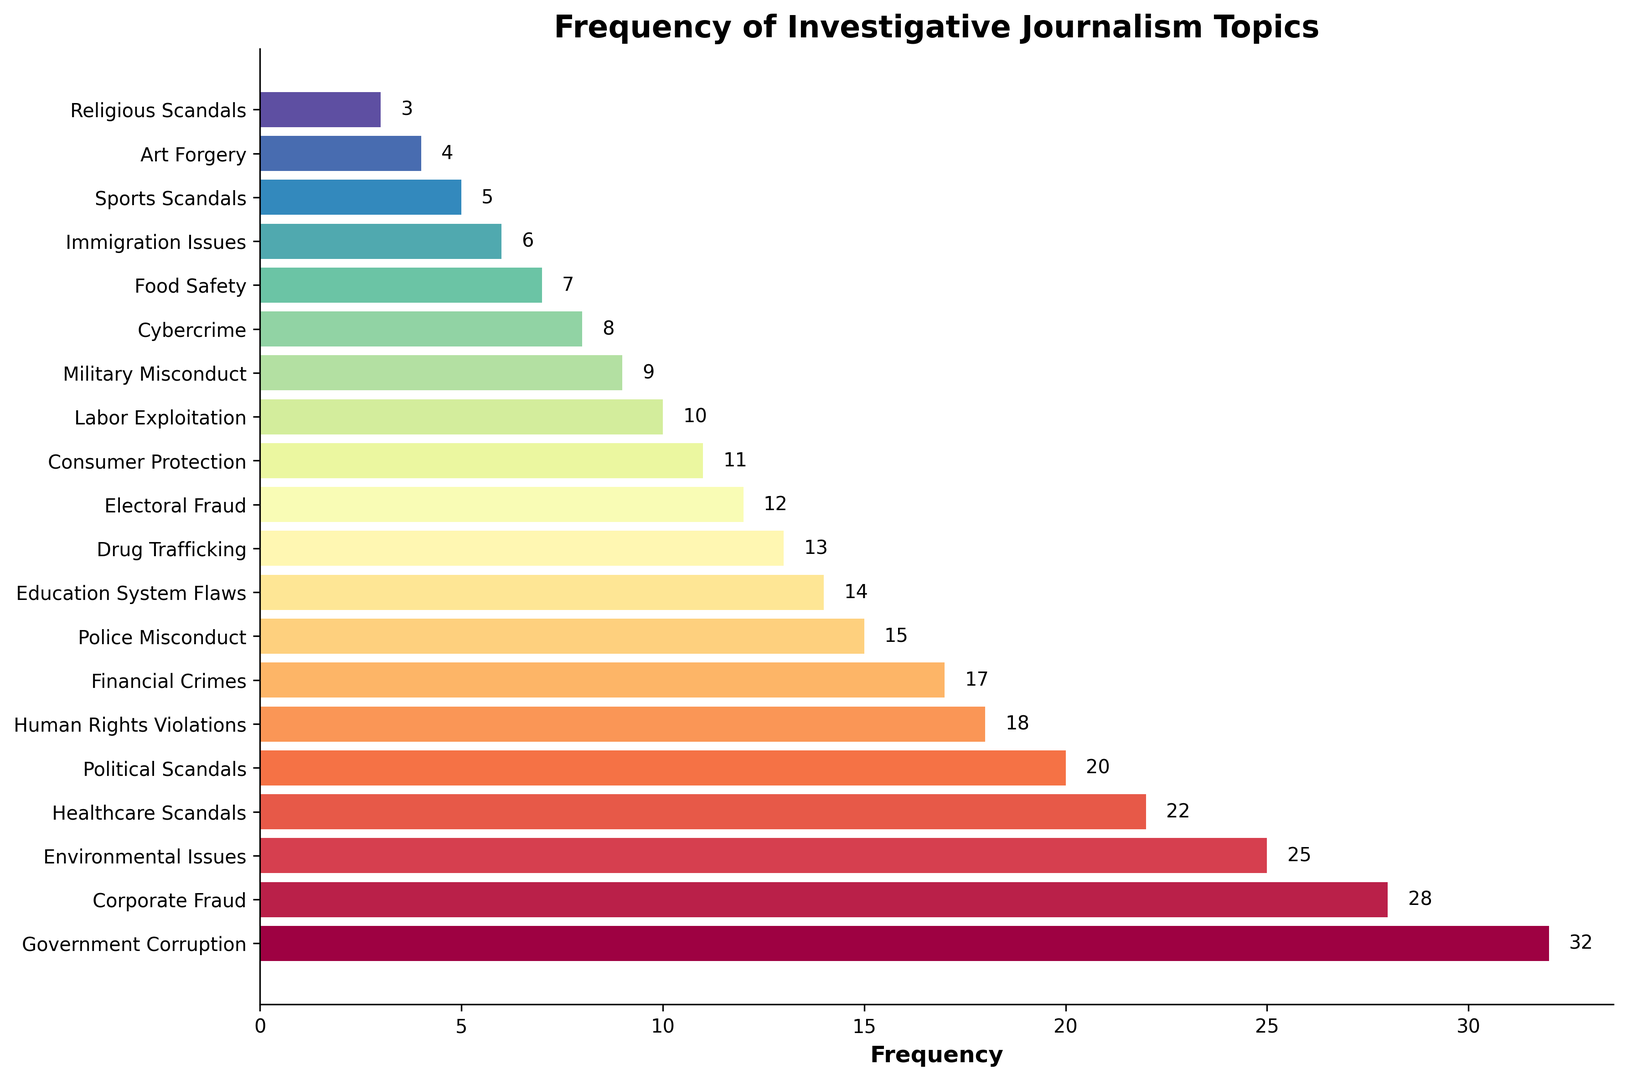Which topic has the highest frequency? The topic with the highest frequency is the tallest bar in the chart. The tallest bar corresponds to 'Government Corruption' with a frequency of 32.
Answer: Government Corruption Which topic has the lowest frequency? The topic with the lowest frequency is the shortest bar in the chart. The shortest bar corresponds to 'Religious Scandals' with a frequency of 3.
Answer: Religious Scandals How many topics have a frequency greater than 20? Count the number of bars with a width greater than 20. The topics are 'Government Corruption', 'Corporate Fraud', 'Environmental Issues', and 'Healthcare Scandals'. This makes 4 topics.
Answer: 4 What is the total frequency for 'Financial Crimes' and 'Police Misconduct'? Find the bars corresponding to 'Financial Crimes' and 'Police Misconduct' and add their frequencies. They are 17 and 15, respectively. The total is 17 + 15 = 32.
Answer: 32 What is the average frequency of the top 3 most frequent topics? Identify the top 3 bars ('Government Corruption', 'Corporate Fraud', 'Environmental Issues') and compute their average frequency. The frequencies are 32, 28, and 25. The average is (32 + 28 + 25) / 3 = 28.33.
Answer: 28.33 How many topics have a frequency below the average of all frequencies? First, calculate the average frequency across all topics. The sum of all frequencies is 270 and there are 20 topics. The average is 270 / 20 = 13.5. Then count the bars with a frequency below 13.5. They are 'Drug Trafficking', 'Electoral Fraud', 'Consumer Protection', 'Labor Exploitation', 'Military Misconduct', 'Cybercrime', 'Food Safety', 'Immigration Issues', 'Sports Scandals', and 'Art Forgery', and 'Religious Scandals'. This makes 11 topics.
Answer: 11 Compare the frequency of 'Drug Trafficking' to 'Consumer Protection'. Which one is higher? Locate the bars for 'Drug Trafficking' and 'Consumer Protection'. 'Drug Trafficking' has a frequency of 13, and 'Consumer Protection' has a frequency of 11. Therefore, 'Drug Trafficking' is higher.
Answer: Drug Trafficking If 'Environmental Issues' and 'Healthcare Scandals' combined, what would be their total frequency? Add the frequencies of 'Environmental Issues' and 'Healthcare Scandals'. These are 25 and 22 respectively. The total is 25 + 22 = 47.
Answer: 47 Are there more topics with a frequency less than 10 or greater than 20? Count the number of topics with a frequency less than 10 and those with a frequency greater than 20. Frequencies less than 10 include 'Art Forgery', 'Religious Scandals', 'Immigration Issues', 'Sports Scandals', 'Food Safety', 'Cybercrime', and 'Military Misconduct' (7 topics). Frequencies greater than 20 include 'Government Corruption', 'Corporate Fraud', and 'Environmental Issues', and 'Healthcare Scandals' (4 topics). Consequently, there are more topics with a frequency less than 10.
Answer: Less than 10 What is the frequency difference between 'Healthcare Scandals' and 'Political Scandals'? Subtract the frequency of 'Political Scandals' from 'Healthcare Scandals'. The frequencies are 22 and 20 respectively. The difference is 22 - 20 = 2.
Answer: 2 